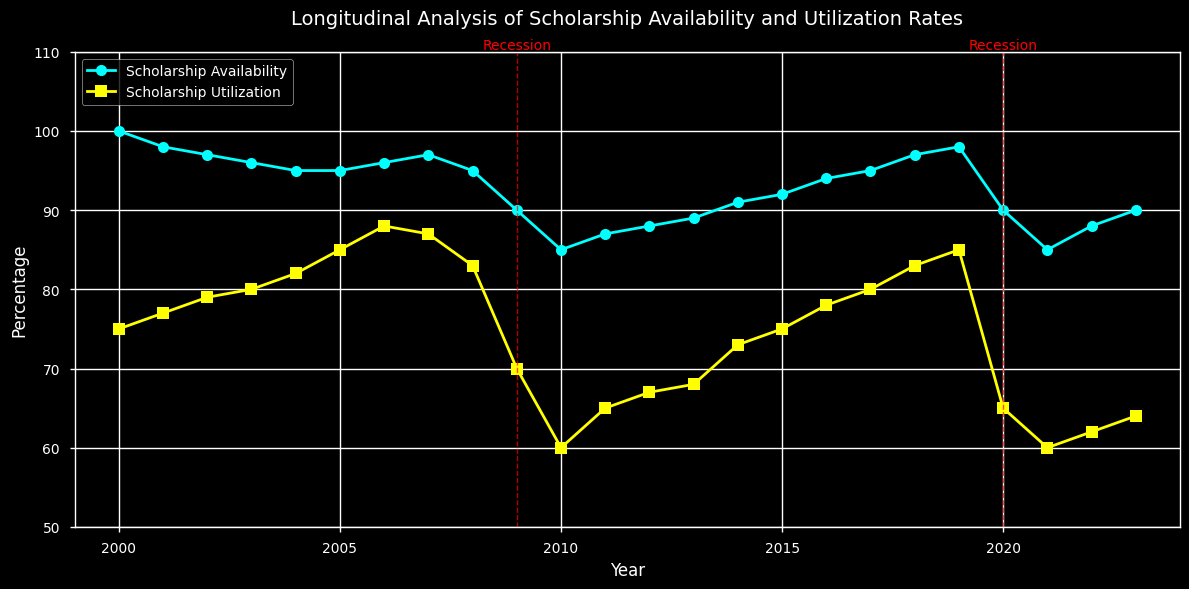What years are marked as economic recessions? The figure shows vertical red dashed lines in the years 2009 and 2020 with annotations labeled "Recession".
Answer: 2009 and 2020 In which year is the gap between Scholarship Availability and Utilization the smallest? By observing the plot, the gap between the two lines is smallest in 2007, where both lines nearly coincide.
Answer: 2007 How did Scholarship Availability change during the recession years? During the recession years (2009 and 2020), Scholarship Availability decreased. It dropped significantly in 2009 and also showed a noticeable decrease in 2020.
Answer: Decreased What is the difference in Scholarship Utilization between the year with the highest utilization and the year with the lowest utilization? The highest Scholarship Utilization occurred in 2006 and 2007 (88%), and the lowest in 2010 and 2021 (60%). The difference is 88% - 60% = 28%.
Answer: 28% What was the average Scholarship Availability from 2010 to 2015? Identify the Scholarship Availability values from 2010 to 2015 (85, 87, 88, 89, 91, 92), then calculate the average: (85 + 87 + 88 + 89 + 91 + 92) / 6 = 88.67 (approx).
Answer: 88.67 Which year experienced the steepest decline in Scholarship Utilization? The plot shows the steepest decline between 2008 and 2009, where Scholarship Utilization dropped from 83 to 70, a difference of 13 points.
Answer: 2009 Compare Scholarship Utilization before and after the 2009 recession. Before 2009, Utilization followed an increasing trend reaching 83. After 2009, it dropped sharply to 70, then gradually climbed again but never reached pre-recession levels.
Answer: Dropped then gradually climbed What is the trend of Scholarship Availability from 2020 to 2023? From 2020 to 2023, Scholarship Availability initially decreased in 2021, then increased in 2022 and 2023.
Answer: Decreasing then increasing 